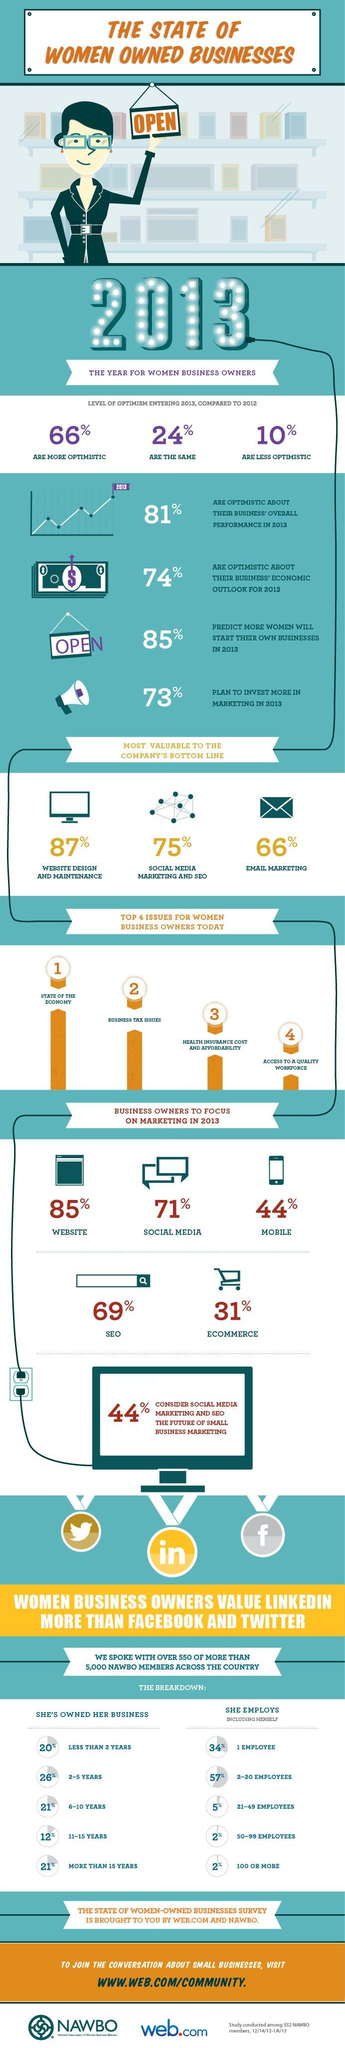Draw attention to some important aspects in this diagram. Approximately 2% of women-owned businesses employed 50 to 100 or more employees. For a woman business owner, tax issues related to their business rank as the second most pressing concern, following closely behind concerns related to the overall success and growth of their business. According to the information provided, 44% of business owners are currently concentrating on mobile marketing. According to the data, 21% of businesses were owned for 6-10 years or 15 years or more. In 2013, a survey found that only 24% of women entrepreneurs were neither overly optimistic nor overly pessimistic about their business prospects. 